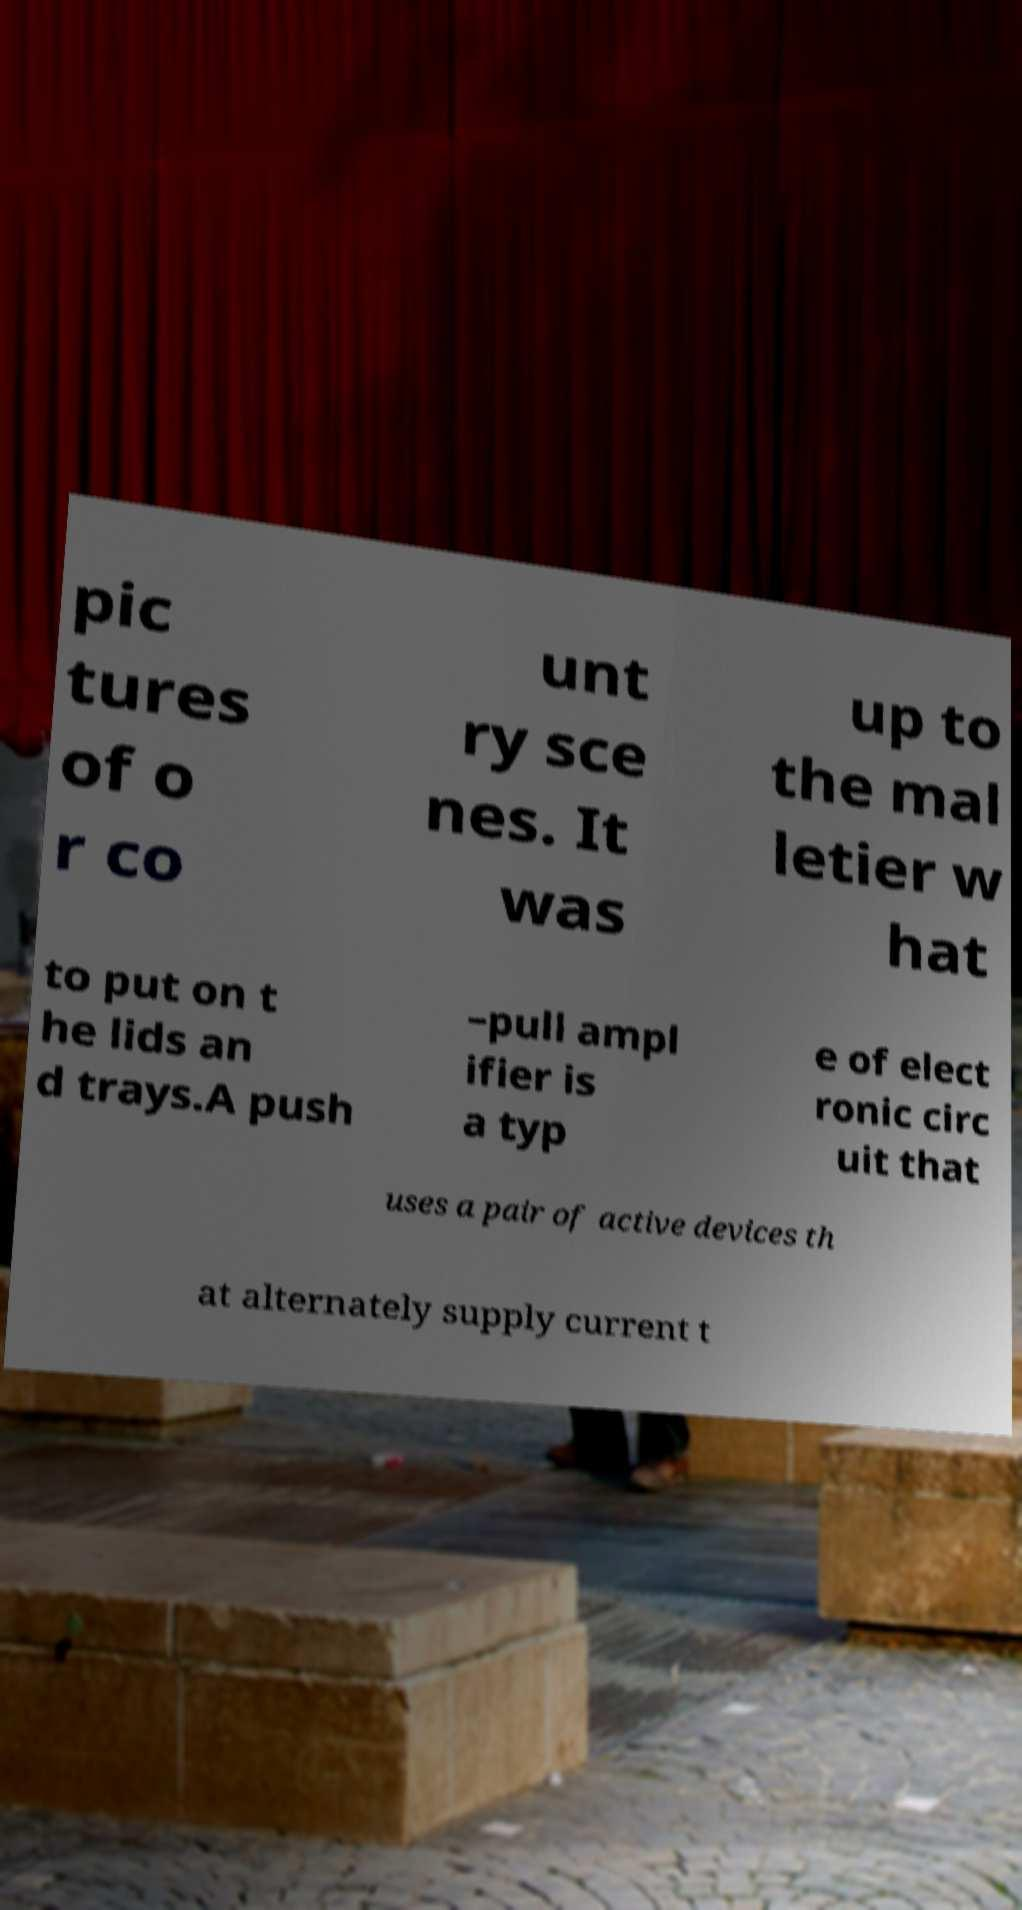Please read and relay the text visible in this image. What does it say? pic tures of o r co unt ry sce nes. It was up to the mal letier w hat to put on t he lids an d trays.A push –pull ampl ifier is a typ e of elect ronic circ uit that uses a pair of active devices th at alternately supply current t 